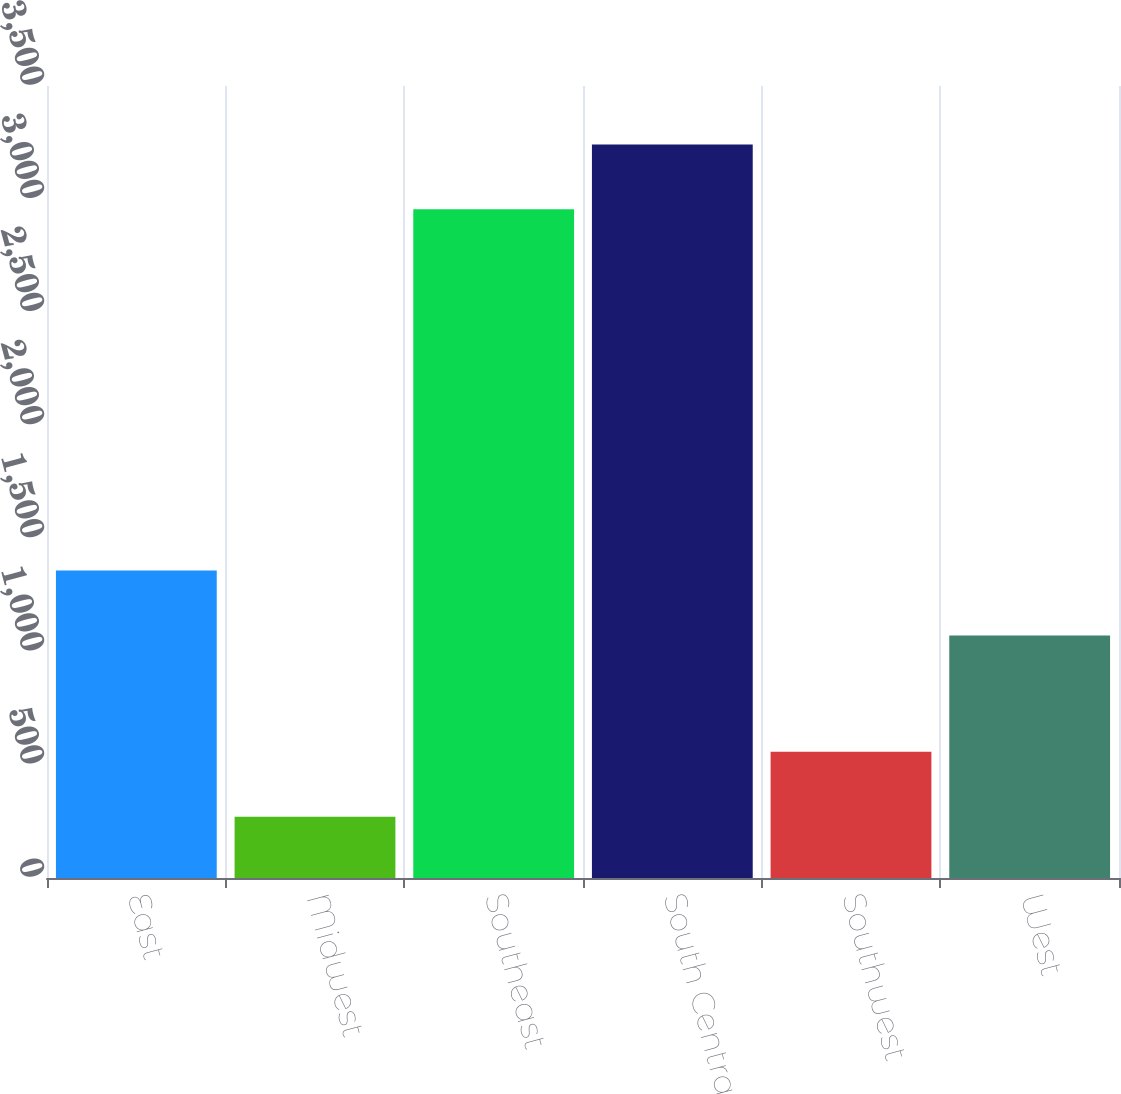<chart> <loc_0><loc_0><loc_500><loc_500><bar_chart><fcel>East<fcel>Midwest<fcel>Southeast<fcel>South Central<fcel>Southwest<fcel>West<nl><fcel>1358.5<fcel>271<fcel>2955<fcel>3241.5<fcel>557.5<fcel>1072<nl></chart> 